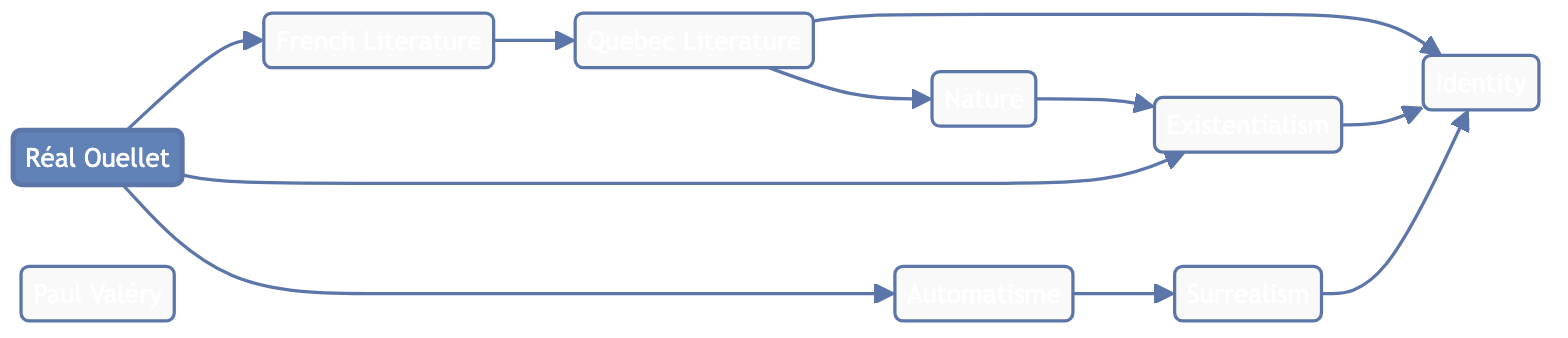What is the central node in the diagram? The central node, which is the main focus of the diagram, is "Réal Ouellet." It is the starting point from which various literary influences and themes branch out.
Answer: Réal Ouellet How many nodes are present in the diagram? To determine the number of nodes, we can count each unique literary concept and author represented in the diagram. There are 9 nodes in total.
Answer: 9 Which node connects "Réal Ouellet" to "Quebec Literature"? The node that directly connects "Réal Ouellet" to "Quebec Literature" is "French Literature." This shows the influence of French literature on Quebec literature and subsequently on Ouellet's works.
Answer: French Literature What type of literature is directly connected to "Automatisme"? The "Surrealism" node is directly connected to "Automatisme," indicating that these two movements share influences and themes in Ouellet's work.
Answer: Surrealism What themes are connected to the node "Quebec Literature"? The themes connected to "Quebec Literature" are "Identity" and "Nature." This indicates that Quebec literature explores these themes significantly.
Answer: Identity, Nature Which literary influence directly leads to the theme of "Existentialism"? The node "Nature" connects directly to "Existentialism." This suggests that Ouellet incorporates elements of nature in exploring existential themes.
Answer: Nature Which node has the most outgoing edges? The node "Quebec Literature" has the most outgoing edges as it is linked to "Identity" and "Nature," affecting multiple areas within the diagram.
Answer: Quebec Literature Which themes are influenced by "Existentialism"? The themes influenced by "Existentialism" are "Identity" and "Nature." This signifies the exploration of personal and universal themes in relation to existence.
Answer: Identity, Nature Which literary concept connects both "Automatisme" and "Surrealism"? The node "Automatisme" connects to "Surrealism." This link indicates that automatism serves as a bridge to surrealist ideas in literature.
Answer: Surrealism 